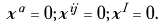<formula> <loc_0><loc_0><loc_500><loc_500>x ^ { \alpha } = 0 ; x ^ { i j } = 0 ; x ^ { I } = 0 .</formula> 